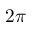Convert formula to latex. <formula><loc_0><loc_0><loc_500><loc_500>2 \pi</formula> 